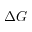Convert formula to latex. <formula><loc_0><loc_0><loc_500><loc_500>\Delta G</formula> 